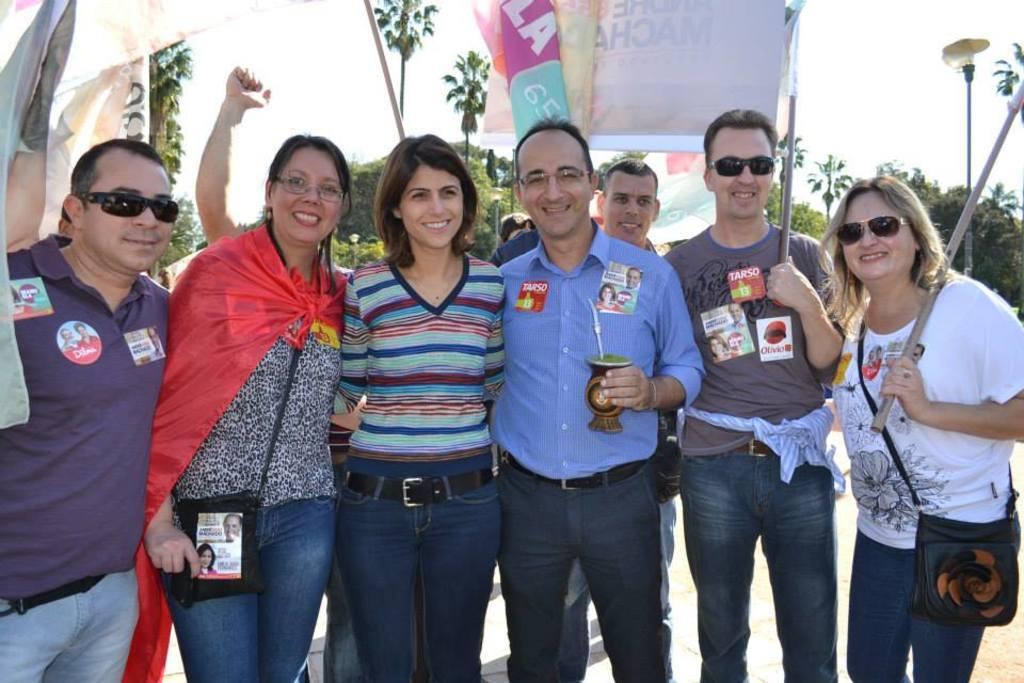How would you summarize this image in a sentence or two? In this image there are group of people standing and smiling, and there are banners, trees, and in the background there is sky. 